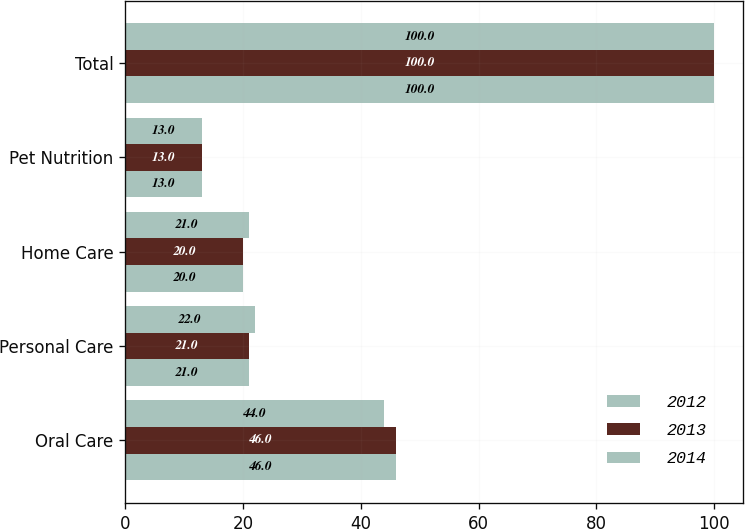Convert chart. <chart><loc_0><loc_0><loc_500><loc_500><stacked_bar_chart><ecel><fcel>Oral Care<fcel>Personal Care<fcel>Home Care<fcel>Pet Nutrition<fcel>Total<nl><fcel>2012<fcel>46<fcel>21<fcel>20<fcel>13<fcel>100<nl><fcel>2013<fcel>46<fcel>21<fcel>20<fcel>13<fcel>100<nl><fcel>2014<fcel>44<fcel>22<fcel>21<fcel>13<fcel>100<nl></chart> 